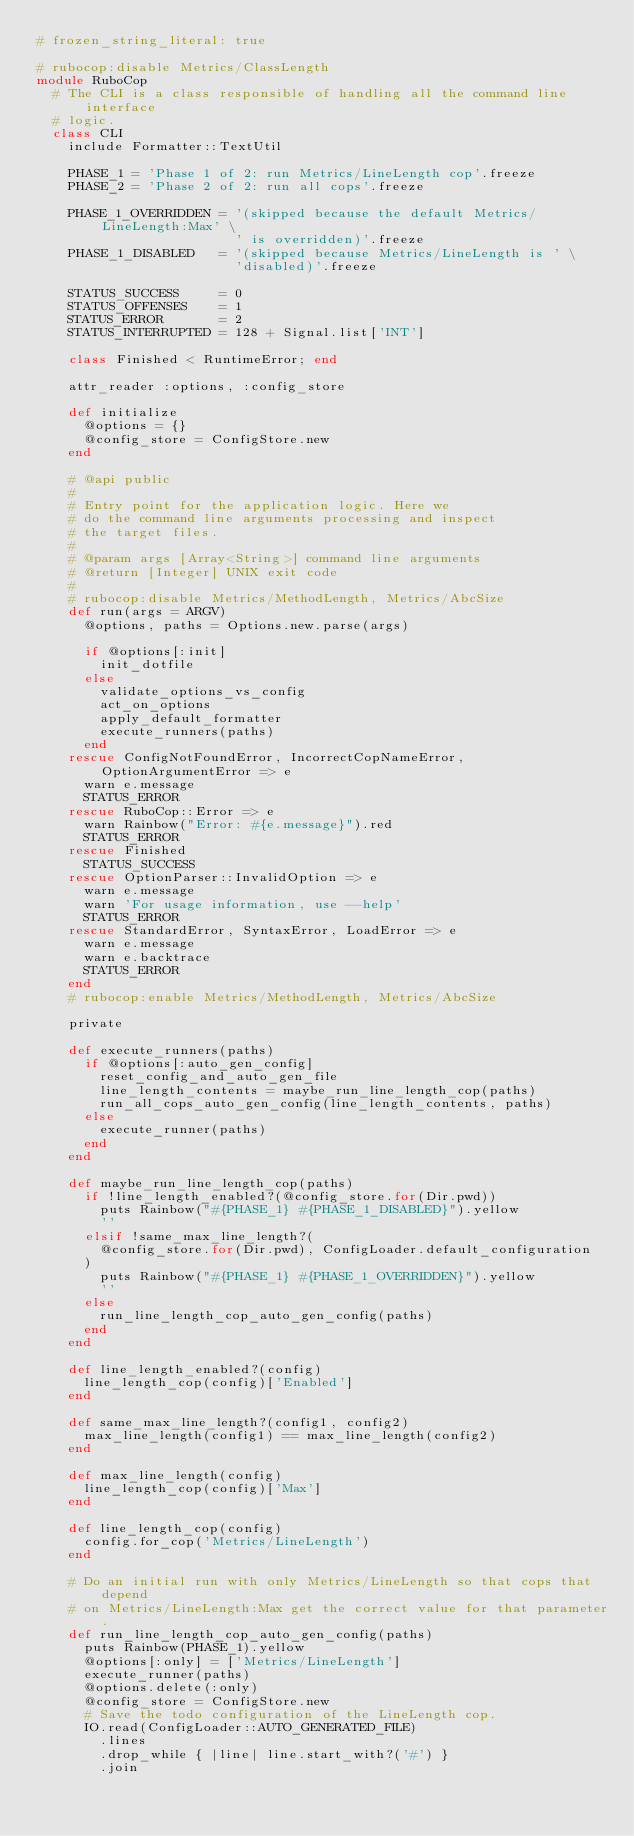<code> <loc_0><loc_0><loc_500><loc_500><_Ruby_># frozen_string_literal: true

# rubocop:disable Metrics/ClassLength
module RuboCop
  # The CLI is a class responsible of handling all the command line interface
  # logic.
  class CLI
    include Formatter::TextUtil

    PHASE_1 = 'Phase 1 of 2: run Metrics/LineLength cop'.freeze
    PHASE_2 = 'Phase 2 of 2: run all cops'.freeze

    PHASE_1_OVERRIDDEN = '(skipped because the default Metrics/LineLength:Max' \
                         ' is overridden)'.freeze
    PHASE_1_DISABLED   = '(skipped because Metrics/LineLength is ' \
                         'disabled)'.freeze

    STATUS_SUCCESS     = 0
    STATUS_OFFENSES    = 1
    STATUS_ERROR       = 2
    STATUS_INTERRUPTED = 128 + Signal.list['INT']

    class Finished < RuntimeError; end

    attr_reader :options, :config_store

    def initialize
      @options = {}
      @config_store = ConfigStore.new
    end

    # @api public
    #
    # Entry point for the application logic. Here we
    # do the command line arguments processing and inspect
    # the target files.
    #
    # @param args [Array<String>] command line arguments
    # @return [Integer] UNIX exit code
    #
    # rubocop:disable Metrics/MethodLength, Metrics/AbcSize
    def run(args = ARGV)
      @options, paths = Options.new.parse(args)

      if @options[:init]
        init_dotfile
      else
        validate_options_vs_config
        act_on_options
        apply_default_formatter
        execute_runners(paths)
      end
    rescue ConfigNotFoundError, IncorrectCopNameError, OptionArgumentError => e
      warn e.message
      STATUS_ERROR
    rescue RuboCop::Error => e
      warn Rainbow("Error: #{e.message}").red
      STATUS_ERROR
    rescue Finished
      STATUS_SUCCESS
    rescue OptionParser::InvalidOption => e
      warn e.message
      warn 'For usage information, use --help'
      STATUS_ERROR
    rescue StandardError, SyntaxError, LoadError => e
      warn e.message
      warn e.backtrace
      STATUS_ERROR
    end
    # rubocop:enable Metrics/MethodLength, Metrics/AbcSize

    private

    def execute_runners(paths)
      if @options[:auto_gen_config]
        reset_config_and_auto_gen_file
        line_length_contents = maybe_run_line_length_cop(paths)
        run_all_cops_auto_gen_config(line_length_contents, paths)
      else
        execute_runner(paths)
      end
    end

    def maybe_run_line_length_cop(paths)
      if !line_length_enabled?(@config_store.for(Dir.pwd))
        puts Rainbow("#{PHASE_1} #{PHASE_1_DISABLED}").yellow
        ''
      elsif !same_max_line_length?(
        @config_store.for(Dir.pwd), ConfigLoader.default_configuration
      )
        puts Rainbow("#{PHASE_1} #{PHASE_1_OVERRIDDEN}").yellow
        ''
      else
        run_line_length_cop_auto_gen_config(paths)
      end
    end

    def line_length_enabled?(config)
      line_length_cop(config)['Enabled']
    end

    def same_max_line_length?(config1, config2)
      max_line_length(config1) == max_line_length(config2)
    end

    def max_line_length(config)
      line_length_cop(config)['Max']
    end

    def line_length_cop(config)
      config.for_cop('Metrics/LineLength')
    end

    # Do an initial run with only Metrics/LineLength so that cops that depend
    # on Metrics/LineLength:Max get the correct value for that parameter.
    def run_line_length_cop_auto_gen_config(paths)
      puts Rainbow(PHASE_1).yellow
      @options[:only] = ['Metrics/LineLength']
      execute_runner(paths)
      @options.delete(:only)
      @config_store = ConfigStore.new
      # Save the todo configuration of the LineLength cop.
      IO.read(ConfigLoader::AUTO_GENERATED_FILE)
        .lines
        .drop_while { |line| line.start_with?('#') }
        .join</code> 